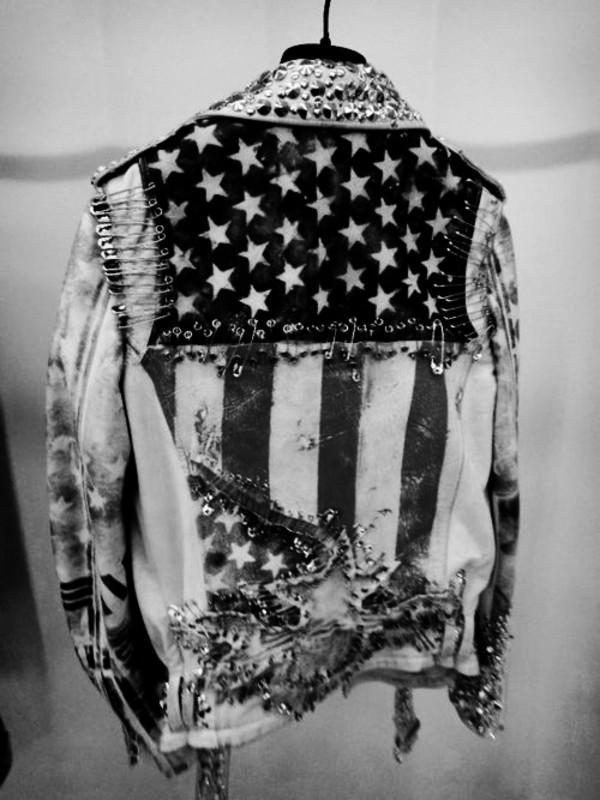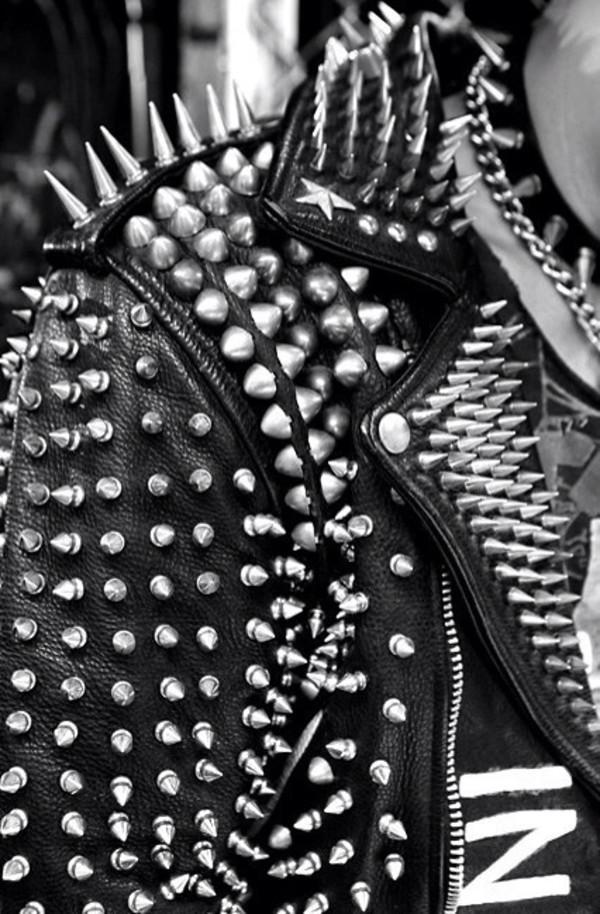The first image is the image on the left, the second image is the image on the right. For the images shown, is this caption "One of the images features a jacket held together with several safety pins." true? Answer yes or no. Yes. 